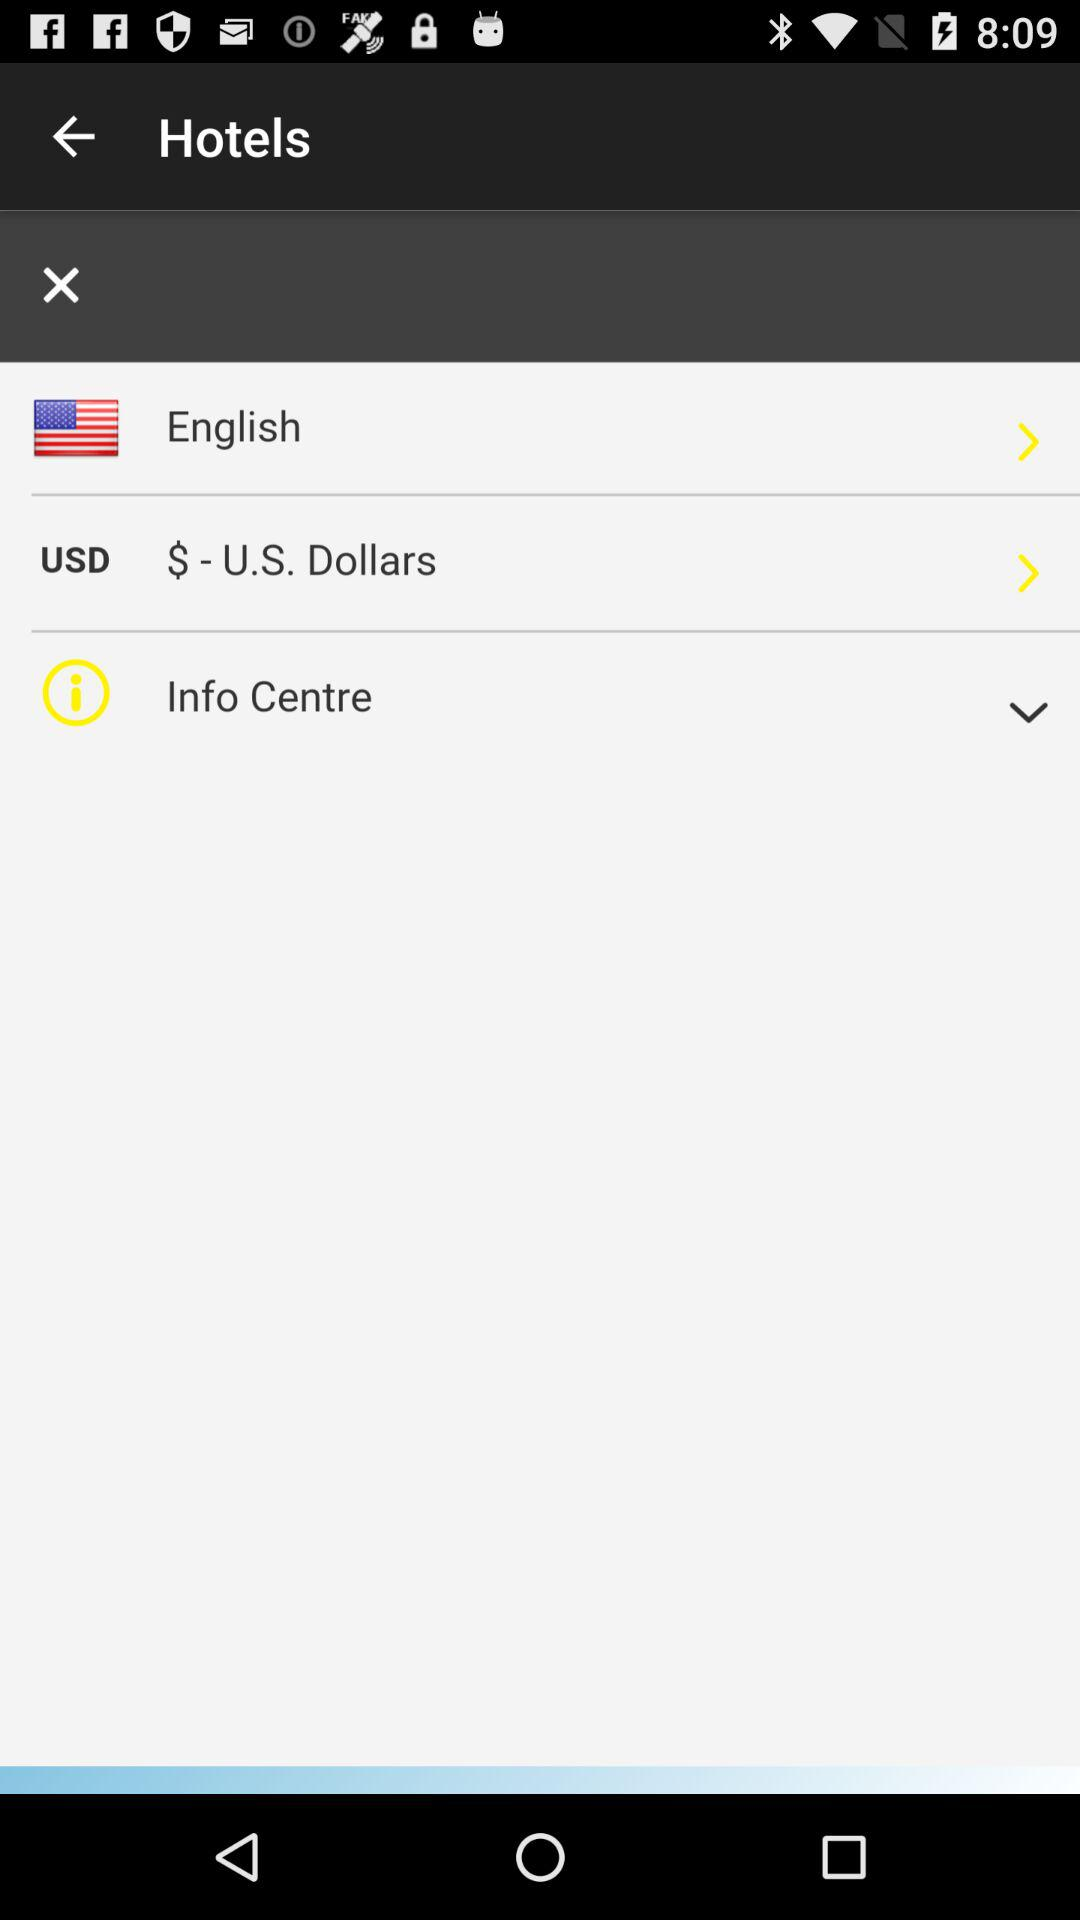Can you describe what information might be available in the 'Info Centre' as shown in the image? The 'Info Centre' section in the app likely serves as a resource for users to access additional details and support. This could include FAQs, contact information, user guides, and possibly tools for managing bookings or reservations. 